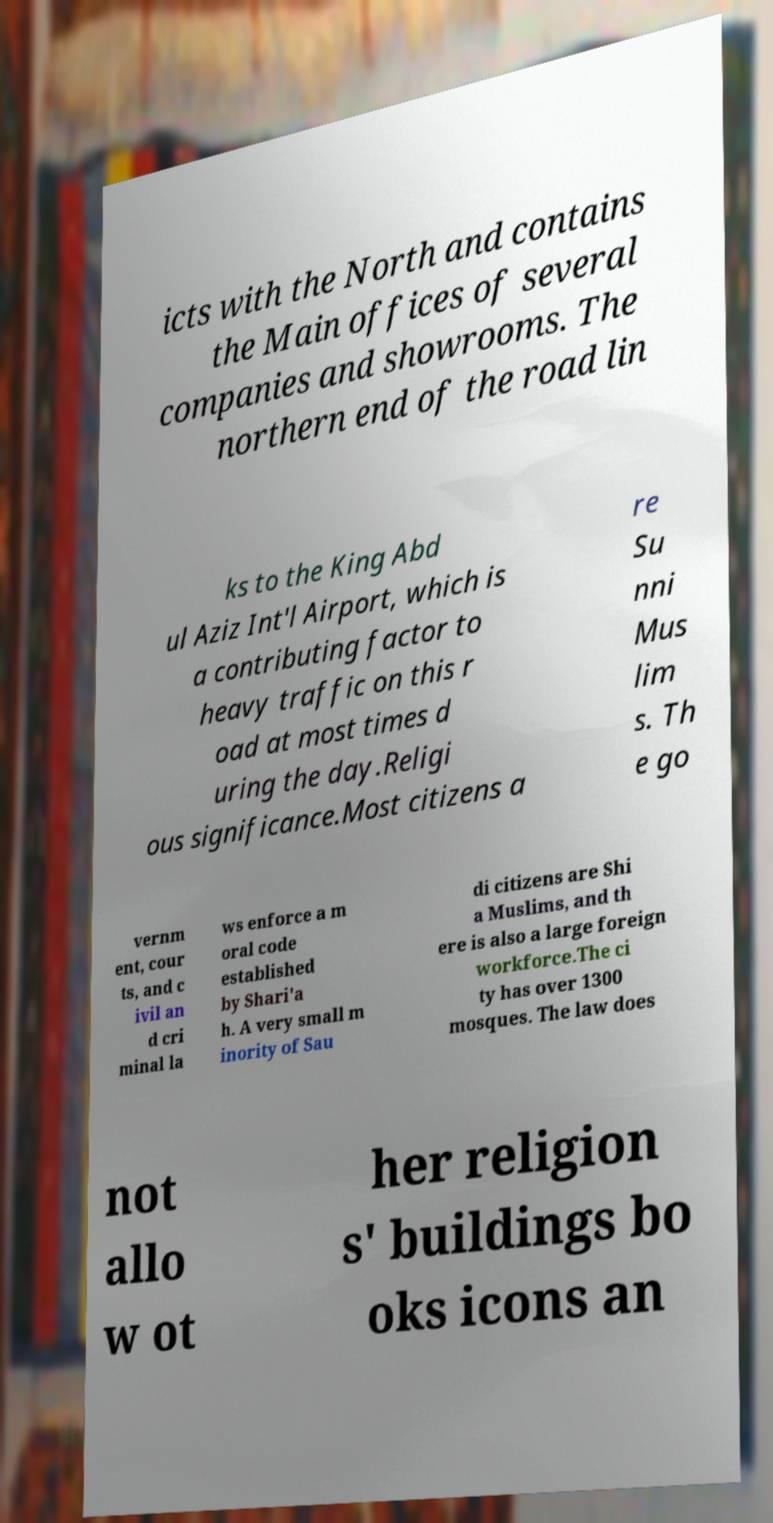Could you extract and type out the text from this image? icts with the North and contains the Main offices of several companies and showrooms. The northern end of the road lin ks to the King Abd ul Aziz Int'l Airport, which is a contributing factor to heavy traffic on this r oad at most times d uring the day.Religi ous significance.Most citizens a re Su nni Mus lim s. Th e go vernm ent, cour ts, and c ivil an d cri minal la ws enforce a m oral code established by Shari'a h. A very small m inority of Sau di citizens are Shi a Muslims, and th ere is also a large foreign workforce.The ci ty has over 1300 mosques. The law does not allo w ot her religion s' buildings bo oks icons an 